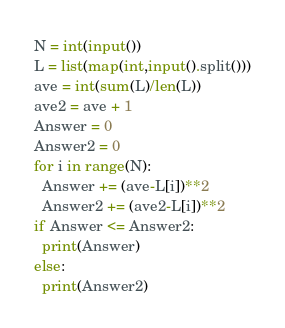Convert code to text. <code><loc_0><loc_0><loc_500><loc_500><_Python_>N = int(input())
L = list(map(int,input().split()))
ave = int(sum(L)/len(L))
ave2 = ave + 1
Answer = 0
Answer2 = 0
for i in range(N):
  Answer += (ave-L[i])**2
  Answer2 += (ave2-L[i])**2
if Answer <= Answer2:
  print(Answer)
else:
  print(Answer2)</code> 